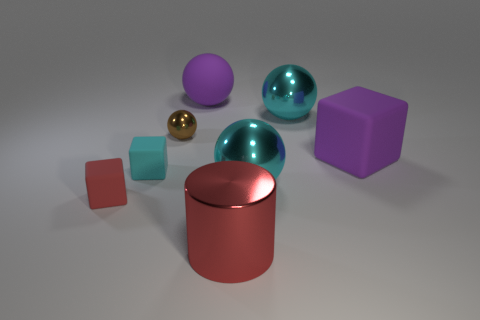Are there any cyan balls made of the same material as the small red thing?
Your answer should be very brief. No. What number of large shiny things are in front of the cyan matte cube and to the right of the big shiny cylinder?
Ensure brevity in your answer.  1. What material is the red thing that is to the left of the purple rubber sphere?
Give a very brief answer. Rubber. The ball that is made of the same material as the tiny red block is what size?
Offer a very short reply. Large. Are there any big blocks right of the big purple ball?
Offer a very short reply. Yes. The purple thing that is the same shape as the red matte object is what size?
Offer a terse response. Large. Is the color of the large rubber cube the same as the large matte object that is on the left side of the purple cube?
Give a very brief answer. Yes. Is the color of the big matte ball the same as the large matte block?
Offer a very short reply. Yes. Are there fewer tiny brown balls than tiny cyan matte cylinders?
Offer a very short reply. No. What number of other things are the same color as the metallic cylinder?
Ensure brevity in your answer.  1. 